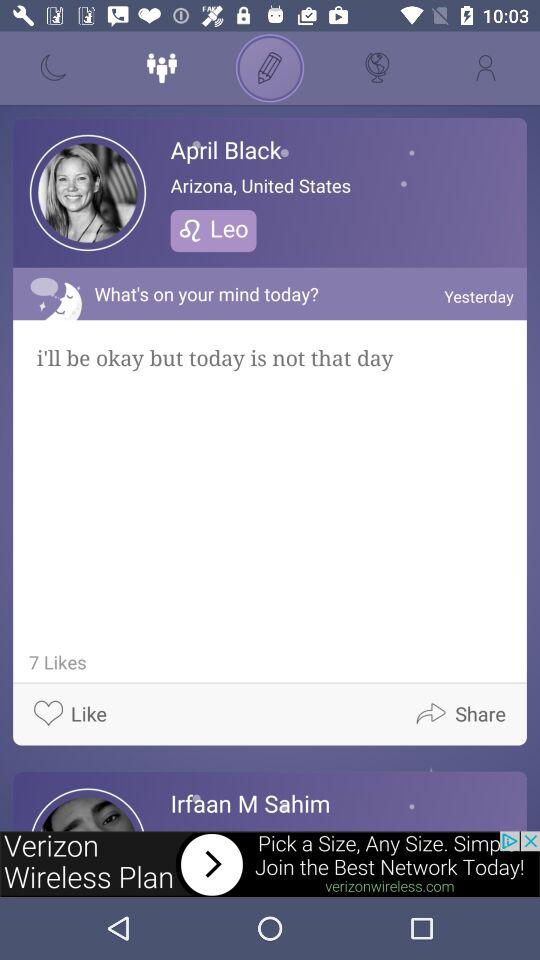What time April Black upload the post?
When the provided information is insufficient, respond with <no answer>. <no answer> 